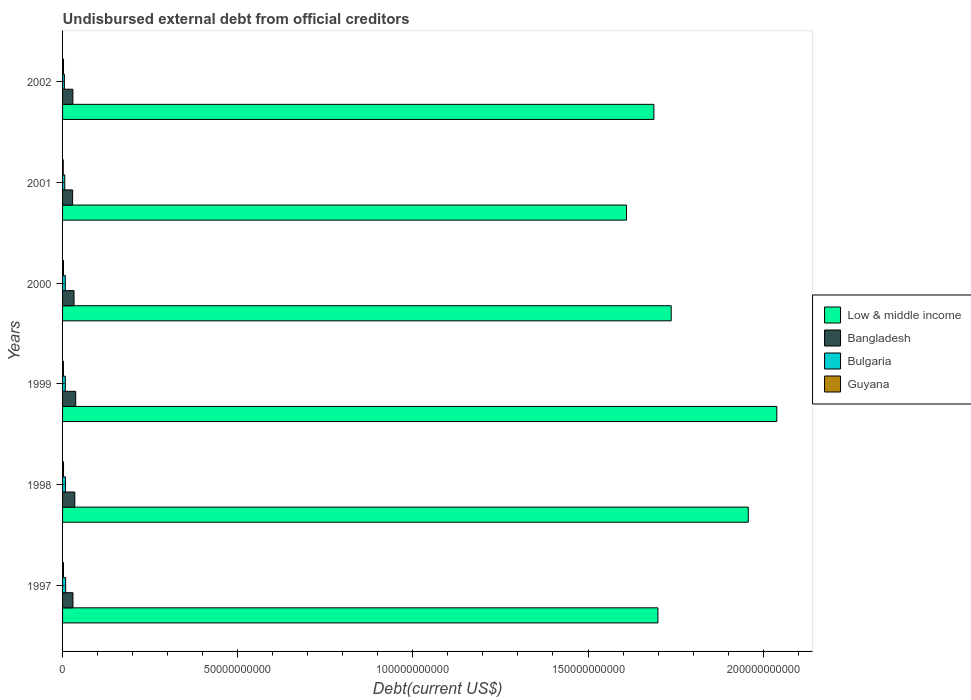How many different coloured bars are there?
Make the answer very short. 4. Are the number of bars per tick equal to the number of legend labels?
Give a very brief answer. Yes. How many bars are there on the 2nd tick from the bottom?
Your response must be concise. 4. What is the label of the 5th group of bars from the top?
Offer a terse response. 1998. In how many cases, is the number of bars for a given year not equal to the number of legend labels?
Ensure brevity in your answer.  0. What is the total debt in Guyana in 1999?
Provide a succinct answer. 2.46e+08. Across all years, what is the maximum total debt in Guyana?
Ensure brevity in your answer.  2.77e+08. Across all years, what is the minimum total debt in Guyana?
Provide a short and direct response. 2.00e+08. In which year was the total debt in Guyana minimum?
Give a very brief answer. 2001. What is the total total debt in Bulgaria in the graph?
Offer a terse response. 4.41e+09. What is the difference between the total debt in Guyana in 1998 and that in 2001?
Make the answer very short. 7.62e+07. What is the difference between the total debt in Bulgaria in 1997 and the total debt in Bangladesh in 2002?
Give a very brief answer. -2.07e+09. What is the average total debt in Bangladesh per year?
Offer a terse response. 3.22e+09. In the year 2000, what is the difference between the total debt in Bulgaria and total debt in Low & middle income?
Provide a succinct answer. -1.73e+11. In how many years, is the total debt in Guyana greater than 60000000000 US$?
Your answer should be very brief. 0. What is the ratio of the total debt in Guyana in 1999 to that in 2002?
Your response must be concise. 0.9. Is the difference between the total debt in Bulgaria in 1997 and 1999 greater than the difference between the total debt in Low & middle income in 1997 and 1999?
Your answer should be very brief. Yes. What is the difference between the highest and the second highest total debt in Bangladesh?
Make the answer very short. 2.61e+08. What is the difference between the highest and the lowest total debt in Guyana?
Provide a short and direct response. 7.62e+07. Is it the case that in every year, the sum of the total debt in Bulgaria and total debt in Bangladesh is greater than the sum of total debt in Guyana and total debt in Low & middle income?
Offer a very short reply. No. What does the 3rd bar from the top in 2002 represents?
Make the answer very short. Bangladesh. What does the 1st bar from the bottom in 2000 represents?
Offer a very short reply. Low & middle income. How many bars are there?
Give a very brief answer. 24. Are all the bars in the graph horizontal?
Make the answer very short. Yes. How many years are there in the graph?
Give a very brief answer. 6. What is the difference between two consecutive major ticks on the X-axis?
Your response must be concise. 5.00e+1. How many legend labels are there?
Offer a terse response. 4. What is the title of the graph?
Your answer should be very brief. Undisbursed external debt from official creditors. What is the label or title of the X-axis?
Give a very brief answer. Debt(current US$). What is the Debt(current US$) of Low & middle income in 1997?
Provide a short and direct response. 1.70e+11. What is the Debt(current US$) in Bangladesh in 1997?
Provide a succinct answer. 2.97e+09. What is the Debt(current US$) of Bulgaria in 1997?
Provide a short and direct response. 8.80e+08. What is the Debt(current US$) in Guyana in 1997?
Your response must be concise. 2.68e+08. What is the Debt(current US$) of Low & middle income in 1998?
Your response must be concise. 1.96e+11. What is the Debt(current US$) in Bangladesh in 1998?
Provide a succinct answer. 3.49e+09. What is the Debt(current US$) in Bulgaria in 1998?
Your answer should be very brief. 8.18e+08. What is the Debt(current US$) of Guyana in 1998?
Offer a terse response. 2.77e+08. What is the Debt(current US$) of Low & middle income in 1999?
Provide a succinct answer. 2.04e+11. What is the Debt(current US$) of Bangladesh in 1999?
Your answer should be compact. 3.76e+09. What is the Debt(current US$) of Bulgaria in 1999?
Provide a succinct answer. 7.88e+08. What is the Debt(current US$) in Guyana in 1999?
Your response must be concise. 2.46e+08. What is the Debt(current US$) in Low & middle income in 2000?
Your answer should be compact. 1.74e+11. What is the Debt(current US$) of Bangladesh in 2000?
Keep it short and to the point. 3.27e+09. What is the Debt(current US$) of Bulgaria in 2000?
Your answer should be very brief. 7.80e+08. What is the Debt(current US$) in Guyana in 2000?
Your response must be concise. 2.62e+08. What is the Debt(current US$) of Low & middle income in 2001?
Keep it short and to the point. 1.61e+11. What is the Debt(current US$) of Bangladesh in 2001?
Your answer should be very brief. 2.87e+09. What is the Debt(current US$) in Bulgaria in 2001?
Offer a terse response. 6.29e+08. What is the Debt(current US$) of Guyana in 2001?
Offer a terse response. 2.00e+08. What is the Debt(current US$) in Low & middle income in 2002?
Ensure brevity in your answer.  1.69e+11. What is the Debt(current US$) in Bangladesh in 2002?
Keep it short and to the point. 2.95e+09. What is the Debt(current US$) of Bulgaria in 2002?
Ensure brevity in your answer.  5.16e+08. What is the Debt(current US$) of Guyana in 2002?
Make the answer very short. 2.72e+08. Across all years, what is the maximum Debt(current US$) in Low & middle income?
Your answer should be compact. 2.04e+11. Across all years, what is the maximum Debt(current US$) of Bangladesh?
Give a very brief answer. 3.76e+09. Across all years, what is the maximum Debt(current US$) of Bulgaria?
Your response must be concise. 8.80e+08. Across all years, what is the maximum Debt(current US$) in Guyana?
Your answer should be compact. 2.77e+08. Across all years, what is the minimum Debt(current US$) of Low & middle income?
Keep it short and to the point. 1.61e+11. Across all years, what is the minimum Debt(current US$) of Bangladesh?
Offer a very short reply. 2.87e+09. Across all years, what is the minimum Debt(current US$) in Bulgaria?
Provide a succinct answer. 5.16e+08. Across all years, what is the minimum Debt(current US$) in Guyana?
Your answer should be very brief. 2.00e+08. What is the total Debt(current US$) of Low & middle income in the graph?
Make the answer very short. 1.07e+12. What is the total Debt(current US$) in Bangladesh in the graph?
Provide a short and direct response. 1.93e+1. What is the total Debt(current US$) of Bulgaria in the graph?
Ensure brevity in your answer.  4.41e+09. What is the total Debt(current US$) in Guyana in the graph?
Ensure brevity in your answer.  1.53e+09. What is the difference between the Debt(current US$) in Low & middle income in 1997 and that in 1998?
Provide a succinct answer. -2.58e+1. What is the difference between the Debt(current US$) in Bangladesh in 1997 and that in 1998?
Offer a terse response. -5.28e+08. What is the difference between the Debt(current US$) of Bulgaria in 1997 and that in 1998?
Your answer should be very brief. 6.22e+07. What is the difference between the Debt(current US$) in Guyana in 1997 and that in 1998?
Offer a very short reply. -8.23e+06. What is the difference between the Debt(current US$) in Low & middle income in 1997 and that in 1999?
Offer a terse response. -3.39e+1. What is the difference between the Debt(current US$) in Bangladesh in 1997 and that in 1999?
Offer a very short reply. -7.88e+08. What is the difference between the Debt(current US$) of Bulgaria in 1997 and that in 1999?
Your answer should be compact. 9.16e+07. What is the difference between the Debt(current US$) in Guyana in 1997 and that in 1999?
Make the answer very short. 2.25e+07. What is the difference between the Debt(current US$) of Low & middle income in 1997 and that in 2000?
Give a very brief answer. -3.79e+09. What is the difference between the Debt(current US$) of Bangladesh in 1997 and that in 2000?
Ensure brevity in your answer.  -3.04e+08. What is the difference between the Debt(current US$) in Bulgaria in 1997 and that in 2000?
Provide a succinct answer. 9.96e+07. What is the difference between the Debt(current US$) in Guyana in 1997 and that in 2000?
Your answer should be very brief. 5.98e+06. What is the difference between the Debt(current US$) of Low & middle income in 1997 and that in 2001?
Provide a short and direct response. 8.98e+09. What is the difference between the Debt(current US$) of Bangladesh in 1997 and that in 2001?
Your answer should be compact. 9.69e+07. What is the difference between the Debt(current US$) in Bulgaria in 1997 and that in 2001?
Your answer should be very brief. 2.50e+08. What is the difference between the Debt(current US$) in Guyana in 1997 and that in 2001?
Offer a very short reply. 6.80e+07. What is the difference between the Debt(current US$) of Low & middle income in 1997 and that in 2002?
Give a very brief answer. 1.16e+09. What is the difference between the Debt(current US$) of Bangladesh in 1997 and that in 2002?
Keep it short and to the point. 1.97e+07. What is the difference between the Debt(current US$) in Bulgaria in 1997 and that in 2002?
Offer a very short reply. 3.63e+08. What is the difference between the Debt(current US$) in Guyana in 1997 and that in 2002?
Make the answer very short. -3.79e+06. What is the difference between the Debt(current US$) of Low & middle income in 1998 and that in 1999?
Provide a succinct answer. -8.15e+09. What is the difference between the Debt(current US$) in Bangladesh in 1998 and that in 1999?
Ensure brevity in your answer.  -2.61e+08. What is the difference between the Debt(current US$) in Bulgaria in 1998 and that in 1999?
Your answer should be compact. 2.94e+07. What is the difference between the Debt(current US$) of Guyana in 1998 and that in 1999?
Keep it short and to the point. 3.07e+07. What is the difference between the Debt(current US$) of Low & middle income in 1998 and that in 2000?
Your answer should be very brief. 2.20e+1. What is the difference between the Debt(current US$) of Bangladesh in 1998 and that in 2000?
Offer a very short reply. 2.23e+08. What is the difference between the Debt(current US$) of Bulgaria in 1998 and that in 2000?
Your response must be concise. 3.74e+07. What is the difference between the Debt(current US$) of Guyana in 1998 and that in 2000?
Provide a short and direct response. 1.42e+07. What is the difference between the Debt(current US$) of Low & middle income in 1998 and that in 2001?
Ensure brevity in your answer.  3.48e+1. What is the difference between the Debt(current US$) in Bangladesh in 1998 and that in 2001?
Keep it short and to the point. 6.24e+08. What is the difference between the Debt(current US$) of Bulgaria in 1998 and that in 2001?
Offer a terse response. 1.88e+08. What is the difference between the Debt(current US$) of Guyana in 1998 and that in 2001?
Keep it short and to the point. 7.62e+07. What is the difference between the Debt(current US$) of Low & middle income in 1998 and that in 2002?
Offer a very short reply. 2.70e+1. What is the difference between the Debt(current US$) of Bangladesh in 1998 and that in 2002?
Your answer should be compact. 5.47e+08. What is the difference between the Debt(current US$) of Bulgaria in 1998 and that in 2002?
Provide a short and direct response. 3.01e+08. What is the difference between the Debt(current US$) of Guyana in 1998 and that in 2002?
Give a very brief answer. 4.44e+06. What is the difference between the Debt(current US$) in Low & middle income in 1999 and that in 2000?
Offer a very short reply. 3.02e+1. What is the difference between the Debt(current US$) of Bangladesh in 1999 and that in 2000?
Give a very brief answer. 4.84e+08. What is the difference between the Debt(current US$) of Bulgaria in 1999 and that in 2000?
Your answer should be very brief. 8.00e+06. What is the difference between the Debt(current US$) in Guyana in 1999 and that in 2000?
Give a very brief answer. -1.65e+07. What is the difference between the Debt(current US$) in Low & middle income in 1999 and that in 2001?
Keep it short and to the point. 4.29e+1. What is the difference between the Debt(current US$) of Bangladesh in 1999 and that in 2001?
Keep it short and to the point. 8.85e+08. What is the difference between the Debt(current US$) in Bulgaria in 1999 and that in 2001?
Your answer should be very brief. 1.59e+08. What is the difference between the Debt(current US$) in Guyana in 1999 and that in 2001?
Offer a very short reply. 4.55e+07. What is the difference between the Debt(current US$) of Low & middle income in 1999 and that in 2002?
Give a very brief answer. 3.51e+1. What is the difference between the Debt(current US$) of Bangladesh in 1999 and that in 2002?
Offer a terse response. 8.08e+08. What is the difference between the Debt(current US$) of Bulgaria in 1999 and that in 2002?
Keep it short and to the point. 2.72e+08. What is the difference between the Debt(current US$) in Guyana in 1999 and that in 2002?
Provide a succinct answer. -2.63e+07. What is the difference between the Debt(current US$) in Low & middle income in 2000 and that in 2001?
Ensure brevity in your answer.  1.28e+1. What is the difference between the Debt(current US$) of Bangladesh in 2000 and that in 2001?
Ensure brevity in your answer.  4.01e+08. What is the difference between the Debt(current US$) of Bulgaria in 2000 and that in 2001?
Your answer should be compact. 1.51e+08. What is the difference between the Debt(current US$) in Guyana in 2000 and that in 2001?
Give a very brief answer. 6.20e+07. What is the difference between the Debt(current US$) of Low & middle income in 2000 and that in 2002?
Give a very brief answer. 4.95e+09. What is the difference between the Debt(current US$) in Bangladesh in 2000 and that in 2002?
Give a very brief answer. 3.24e+08. What is the difference between the Debt(current US$) in Bulgaria in 2000 and that in 2002?
Make the answer very short. 2.64e+08. What is the difference between the Debt(current US$) in Guyana in 2000 and that in 2002?
Your answer should be compact. -9.77e+06. What is the difference between the Debt(current US$) of Low & middle income in 2001 and that in 2002?
Your response must be concise. -7.81e+09. What is the difference between the Debt(current US$) of Bangladesh in 2001 and that in 2002?
Offer a very short reply. -7.71e+07. What is the difference between the Debt(current US$) in Bulgaria in 2001 and that in 2002?
Offer a terse response. 1.13e+08. What is the difference between the Debt(current US$) of Guyana in 2001 and that in 2002?
Your answer should be compact. -7.18e+07. What is the difference between the Debt(current US$) of Low & middle income in 1997 and the Debt(current US$) of Bangladesh in 1998?
Ensure brevity in your answer.  1.66e+11. What is the difference between the Debt(current US$) in Low & middle income in 1997 and the Debt(current US$) in Bulgaria in 1998?
Offer a terse response. 1.69e+11. What is the difference between the Debt(current US$) in Low & middle income in 1997 and the Debt(current US$) in Guyana in 1998?
Your answer should be very brief. 1.70e+11. What is the difference between the Debt(current US$) in Bangladesh in 1997 and the Debt(current US$) in Bulgaria in 1998?
Offer a terse response. 2.15e+09. What is the difference between the Debt(current US$) of Bangladesh in 1997 and the Debt(current US$) of Guyana in 1998?
Provide a short and direct response. 2.69e+09. What is the difference between the Debt(current US$) of Bulgaria in 1997 and the Debt(current US$) of Guyana in 1998?
Provide a short and direct response. 6.03e+08. What is the difference between the Debt(current US$) in Low & middle income in 1997 and the Debt(current US$) in Bangladesh in 1999?
Your answer should be very brief. 1.66e+11. What is the difference between the Debt(current US$) in Low & middle income in 1997 and the Debt(current US$) in Bulgaria in 1999?
Make the answer very short. 1.69e+11. What is the difference between the Debt(current US$) in Low & middle income in 1997 and the Debt(current US$) in Guyana in 1999?
Your answer should be very brief. 1.70e+11. What is the difference between the Debt(current US$) of Bangladesh in 1997 and the Debt(current US$) of Bulgaria in 1999?
Offer a terse response. 2.18e+09. What is the difference between the Debt(current US$) of Bangladesh in 1997 and the Debt(current US$) of Guyana in 1999?
Your answer should be very brief. 2.72e+09. What is the difference between the Debt(current US$) in Bulgaria in 1997 and the Debt(current US$) in Guyana in 1999?
Keep it short and to the point. 6.34e+08. What is the difference between the Debt(current US$) of Low & middle income in 1997 and the Debt(current US$) of Bangladesh in 2000?
Give a very brief answer. 1.67e+11. What is the difference between the Debt(current US$) of Low & middle income in 1997 and the Debt(current US$) of Bulgaria in 2000?
Make the answer very short. 1.69e+11. What is the difference between the Debt(current US$) in Low & middle income in 1997 and the Debt(current US$) in Guyana in 2000?
Your answer should be compact. 1.70e+11. What is the difference between the Debt(current US$) in Bangladesh in 1997 and the Debt(current US$) in Bulgaria in 2000?
Your response must be concise. 2.19e+09. What is the difference between the Debt(current US$) of Bangladesh in 1997 and the Debt(current US$) of Guyana in 2000?
Your response must be concise. 2.70e+09. What is the difference between the Debt(current US$) in Bulgaria in 1997 and the Debt(current US$) in Guyana in 2000?
Your response must be concise. 6.17e+08. What is the difference between the Debt(current US$) of Low & middle income in 1997 and the Debt(current US$) of Bangladesh in 2001?
Offer a very short reply. 1.67e+11. What is the difference between the Debt(current US$) of Low & middle income in 1997 and the Debt(current US$) of Bulgaria in 2001?
Give a very brief answer. 1.69e+11. What is the difference between the Debt(current US$) in Low & middle income in 1997 and the Debt(current US$) in Guyana in 2001?
Keep it short and to the point. 1.70e+11. What is the difference between the Debt(current US$) of Bangladesh in 1997 and the Debt(current US$) of Bulgaria in 2001?
Keep it short and to the point. 2.34e+09. What is the difference between the Debt(current US$) of Bangladesh in 1997 and the Debt(current US$) of Guyana in 2001?
Offer a terse response. 2.77e+09. What is the difference between the Debt(current US$) in Bulgaria in 1997 and the Debt(current US$) in Guyana in 2001?
Provide a short and direct response. 6.79e+08. What is the difference between the Debt(current US$) of Low & middle income in 1997 and the Debt(current US$) of Bangladesh in 2002?
Provide a succinct answer. 1.67e+11. What is the difference between the Debt(current US$) in Low & middle income in 1997 and the Debt(current US$) in Bulgaria in 2002?
Your answer should be compact. 1.69e+11. What is the difference between the Debt(current US$) in Low & middle income in 1997 and the Debt(current US$) in Guyana in 2002?
Provide a short and direct response. 1.70e+11. What is the difference between the Debt(current US$) in Bangladesh in 1997 and the Debt(current US$) in Bulgaria in 2002?
Your answer should be very brief. 2.45e+09. What is the difference between the Debt(current US$) in Bangladesh in 1997 and the Debt(current US$) in Guyana in 2002?
Provide a succinct answer. 2.69e+09. What is the difference between the Debt(current US$) in Bulgaria in 1997 and the Debt(current US$) in Guyana in 2002?
Offer a very short reply. 6.07e+08. What is the difference between the Debt(current US$) in Low & middle income in 1998 and the Debt(current US$) in Bangladesh in 1999?
Provide a succinct answer. 1.92e+11. What is the difference between the Debt(current US$) in Low & middle income in 1998 and the Debt(current US$) in Bulgaria in 1999?
Offer a very short reply. 1.95e+11. What is the difference between the Debt(current US$) in Low & middle income in 1998 and the Debt(current US$) in Guyana in 1999?
Keep it short and to the point. 1.96e+11. What is the difference between the Debt(current US$) of Bangladesh in 1998 and the Debt(current US$) of Bulgaria in 1999?
Ensure brevity in your answer.  2.71e+09. What is the difference between the Debt(current US$) in Bangladesh in 1998 and the Debt(current US$) in Guyana in 1999?
Your answer should be very brief. 3.25e+09. What is the difference between the Debt(current US$) of Bulgaria in 1998 and the Debt(current US$) of Guyana in 1999?
Offer a very short reply. 5.72e+08. What is the difference between the Debt(current US$) of Low & middle income in 1998 and the Debt(current US$) of Bangladesh in 2000?
Your answer should be very brief. 1.92e+11. What is the difference between the Debt(current US$) in Low & middle income in 1998 and the Debt(current US$) in Bulgaria in 2000?
Your response must be concise. 1.95e+11. What is the difference between the Debt(current US$) in Low & middle income in 1998 and the Debt(current US$) in Guyana in 2000?
Your answer should be compact. 1.95e+11. What is the difference between the Debt(current US$) of Bangladesh in 1998 and the Debt(current US$) of Bulgaria in 2000?
Give a very brief answer. 2.71e+09. What is the difference between the Debt(current US$) of Bangladesh in 1998 and the Debt(current US$) of Guyana in 2000?
Keep it short and to the point. 3.23e+09. What is the difference between the Debt(current US$) in Bulgaria in 1998 and the Debt(current US$) in Guyana in 2000?
Ensure brevity in your answer.  5.55e+08. What is the difference between the Debt(current US$) of Low & middle income in 1998 and the Debt(current US$) of Bangladesh in 2001?
Make the answer very short. 1.93e+11. What is the difference between the Debt(current US$) in Low & middle income in 1998 and the Debt(current US$) in Bulgaria in 2001?
Give a very brief answer. 1.95e+11. What is the difference between the Debt(current US$) of Low & middle income in 1998 and the Debt(current US$) of Guyana in 2001?
Keep it short and to the point. 1.96e+11. What is the difference between the Debt(current US$) of Bangladesh in 1998 and the Debt(current US$) of Bulgaria in 2001?
Your response must be concise. 2.87e+09. What is the difference between the Debt(current US$) of Bangladesh in 1998 and the Debt(current US$) of Guyana in 2001?
Offer a very short reply. 3.29e+09. What is the difference between the Debt(current US$) in Bulgaria in 1998 and the Debt(current US$) in Guyana in 2001?
Give a very brief answer. 6.17e+08. What is the difference between the Debt(current US$) in Low & middle income in 1998 and the Debt(current US$) in Bangladesh in 2002?
Provide a short and direct response. 1.93e+11. What is the difference between the Debt(current US$) of Low & middle income in 1998 and the Debt(current US$) of Bulgaria in 2002?
Ensure brevity in your answer.  1.95e+11. What is the difference between the Debt(current US$) in Low & middle income in 1998 and the Debt(current US$) in Guyana in 2002?
Provide a short and direct response. 1.95e+11. What is the difference between the Debt(current US$) of Bangladesh in 1998 and the Debt(current US$) of Bulgaria in 2002?
Your response must be concise. 2.98e+09. What is the difference between the Debt(current US$) of Bangladesh in 1998 and the Debt(current US$) of Guyana in 2002?
Give a very brief answer. 3.22e+09. What is the difference between the Debt(current US$) of Bulgaria in 1998 and the Debt(current US$) of Guyana in 2002?
Make the answer very short. 5.45e+08. What is the difference between the Debt(current US$) in Low & middle income in 1999 and the Debt(current US$) in Bangladesh in 2000?
Provide a succinct answer. 2.01e+11. What is the difference between the Debt(current US$) in Low & middle income in 1999 and the Debt(current US$) in Bulgaria in 2000?
Give a very brief answer. 2.03e+11. What is the difference between the Debt(current US$) of Low & middle income in 1999 and the Debt(current US$) of Guyana in 2000?
Your answer should be very brief. 2.04e+11. What is the difference between the Debt(current US$) in Bangladesh in 1999 and the Debt(current US$) in Bulgaria in 2000?
Ensure brevity in your answer.  2.98e+09. What is the difference between the Debt(current US$) of Bangladesh in 1999 and the Debt(current US$) of Guyana in 2000?
Offer a terse response. 3.49e+09. What is the difference between the Debt(current US$) of Bulgaria in 1999 and the Debt(current US$) of Guyana in 2000?
Offer a terse response. 5.26e+08. What is the difference between the Debt(current US$) of Low & middle income in 1999 and the Debt(current US$) of Bangladesh in 2001?
Provide a succinct answer. 2.01e+11. What is the difference between the Debt(current US$) in Low & middle income in 1999 and the Debt(current US$) in Bulgaria in 2001?
Provide a short and direct response. 2.03e+11. What is the difference between the Debt(current US$) of Low & middle income in 1999 and the Debt(current US$) of Guyana in 2001?
Offer a terse response. 2.04e+11. What is the difference between the Debt(current US$) in Bangladesh in 1999 and the Debt(current US$) in Bulgaria in 2001?
Give a very brief answer. 3.13e+09. What is the difference between the Debt(current US$) of Bangladesh in 1999 and the Debt(current US$) of Guyana in 2001?
Keep it short and to the point. 3.55e+09. What is the difference between the Debt(current US$) of Bulgaria in 1999 and the Debt(current US$) of Guyana in 2001?
Provide a short and direct response. 5.88e+08. What is the difference between the Debt(current US$) of Low & middle income in 1999 and the Debt(current US$) of Bangladesh in 2002?
Keep it short and to the point. 2.01e+11. What is the difference between the Debt(current US$) in Low & middle income in 1999 and the Debt(current US$) in Bulgaria in 2002?
Provide a succinct answer. 2.03e+11. What is the difference between the Debt(current US$) in Low & middle income in 1999 and the Debt(current US$) in Guyana in 2002?
Make the answer very short. 2.04e+11. What is the difference between the Debt(current US$) of Bangladesh in 1999 and the Debt(current US$) of Bulgaria in 2002?
Your response must be concise. 3.24e+09. What is the difference between the Debt(current US$) in Bangladesh in 1999 and the Debt(current US$) in Guyana in 2002?
Ensure brevity in your answer.  3.48e+09. What is the difference between the Debt(current US$) of Bulgaria in 1999 and the Debt(current US$) of Guyana in 2002?
Your response must be concise. 5.16e+08. What is the difference between the Debt(current US$) of Low & middle income in 2000 and the Debt(current US$) of Bangladesh in 2001?
Your answer should be compact. 1.71e+11. What is the difference between the Debt(current US$) in Low & middle income in 2000 and the Debt(current US$) in Bulgaria in 2001?
Offer a terse response. 1.73e+11. What is the difference between the Debt(current US$) of Low & middle income in 2000 and the Debt(current US$) of Guyana in 2001?
Provide a succinct answer. 1.74e+11. What is the difference between the Debt(current US$) of Bangladesh in 2000 and the Debt(current US$) of Bulgaria in 2001?
Provide a succinct answer. 2.64e+09. What is the difference between the Debt(current US$) in Bangladesh in 2000 and the Debt(current US$) in Guyana in 2001?
Your response must be concise. 3.07e+09. What is the difference between the Debt(current US$) in Bulgaria in 2000 and the Debt(current US$) in Guyana in 2001?
Ensure brevity in your answer.  5.80e+08. What is the difference between the Debt(current US$) in Low & middle income in 2000 and the Debt(current US$) in Bangladesh in 2002?
Your response must be concise. 1.71e+11. What is the difference between the Debt(current US$) in Low & middle income in 2000 and the Debt(current US$) in Bulgaria in 2002?
Give a very brief answer. 1.73e+11. What is the difference between the Debt(current US$) in Low & middle income in 2000 and the Debt(current US$) in Guyana in 2002?
Give a very brief answer. 1.73e+11. What is the difference between the Debt(current US$) in Bangladesh in 2000 and the Debt(current US$) in Bulgaria in 2002?
Keep it short and to the point. 2.76e+09. What is the difference between the Debt(current US$) in Bangladesh in 2000 and the Debt(current US$) in Guyana in 2002?
Your answer should be very brief. 3.00e+09. What is the difference between the Debt(current US$) in Bulgaria in 2000 and the Debt(current US$) in Guyana in 2002?
Your answer should be very brief. 5.08e+08. What is the difference between the Debt(current US$) in Low & middle income in 2001 and the Debt(current US$) in Bangladesh in 2002?
Provide a succinct answer. 1.58e+11. What is the difference between the Debt(current US$) of Low & middle income in 2001 and the Debt(current US$) of Bulgaria in 2002?
Offer a terse response. 1.60e+11. What is the difference between the Debt(current US$) of Low & middle income in 2001 and the Debt(current US$) of Guyana in 2002?
Give a very brief answer. 1.61e+11. What is the difference between the Debt(current US$) in Bangladesh in 2001 and the Debt(current US$) in Bulgaria in 2002?
Ensure brevity in your answer.  2.35e+09. What is the difference between the Debt(current US$) in Bangladesh in 2001 and the Debt(current US$) in Guyana in 2002?
Offer a terse response. 2.60e+09. What is the difference between the Debt(current US$) of Bulgaria in 2001 and the Debt(current US$) of Guyana in 2002?
Make the answer very short. 3.57e+08. What is the average Debt(current US$) of Low & middle income per year?
Your answer should be very brief. 1.79e+11. What is the average Debt(current US$) of Bangladesh per year?
Keep it short and to the point. 3.22e+09. What is the average Debt(current US$) of Bulgaria per year?
Provide a short and direct response. 7.35e+08. What is the average Debt(current US$) in Guyana per year?
Provide a short and direct response. 2.54e+08. In the year 1997, what is the difference between the Debt(current US$) in Low & middle income and Debt(current US$) in Bangladesh?
Your answer should be compact. 1.67e+11. In the year 1997, what is the difference between the Debt(current US$) of Low & middle income and Debt(current US$) of Bulgaria?
Offer a very short reply. 1.69e+11. In the year 1997, what is the difference between the Debt(current US$) in Low & middle income and Debt(current US$) in Guyana?
Keep it short and to the point. 1.70e+11. In the year 1997, what is the difference between the Debt(current US$) of Bangladesh and Debt(current US$) of Bulgaria?
Provide a short and direct response. 2.09e+09. In the year 1997, what is the difference between the Debt(current US$) in Bangladesh and Debt(current US$) in Guyana?
Your answer should be compact. 2.70e+09. In the year 1997, what is the difference between the Debt(current US$) of Bulgaria and Debt(current US$) of Guyana?
Offer a terse response. 6.11e+08. In the year 1998, what is the difference between the Debt(current US$) in Low & middle income and Debt(current US$) in Bangladesh?
Provide a short and direct response. 1.92e+11. In the year 1998, what is the difference between the Debt(current US$) in Low & middle income and Debt(current US$) in Bulgaria?
Your response must be concise. 1.95e+11. In the year 1998, what is the difference between the Debt(current US$) of Low & middle income and Debt(current US$) of Guyana?
Your answer should be compact. 1.95e+11. In the year 1998, what is the difference between the Debt(current US$) in Bangladesh and Debt(current US$) in Bulgaria?
Your answer should be compact. 2.68e+09. In the year 1998, what is the difference between the Debt(current US$) of Bangladesh and Debt(current US$) of Guyana?
Give a very brief answer. 3.22e+09. In the year 1998, what is the difference between the Debt(current US$) in Bulgaria and Debt(current US$) in Guyana?
Provide a short and direct response. 5.41e+08. In the year 1999, what is the difference between the Debt(current US$) in Low & middle income and Debt(current US$) in Bangladesh?
Your answer should be very brief. 2.00e+11. In the year 1999, what is the difference between the Debt(current US$) of Low & middle income and Debt(current US$) of Bulgaria?
Your answer should be compact. 2.03e+11. In the year 1999, what is the difference between the Debt(current US$) of Low & middle income and Debt(current US$) of Guyana?
Offer a very short reply. 2.04e+11. In the year 1999, what is the difference between the Debt(current US$) of Bangladesh and Debt(current US$) of Bulgaria?
Ensure brevity in your answer.  2.97e+09. In the year 1999, what is the difference between the Debt(current US$) of Bangladesh and Debt(current US$) of Guyana?
Keep it short and to the point. 3.51e+09. In the year 1999, what is the difference between the Debt(current US$) of Bulgaria and Debt(current US$) of Guyana?
Offer a terse response. 5.42e+08. In the year 2000, what is the difference between the Debt(current US$) of Low & middle income and Debt(current US$) of Bangladesh?
Offer a terse response. 1.70e+11. In the year 2000, what is the difference between the Debt(current US$) of Low & middle income and Debt(current US$) of Bulgaria?
Offer a very short reply. 1.73e+11. In the year 2000, what is the difference between the Debt(current US$) in Low & middle income and Debt(current US$) in Guyana?
Offer a very short reply. 1.73e+11. In the year 2000, what is the difference between the Debt(current US$) of Bangladesh and Debt(current US$) of Bulgaria?
Give a very brief answer. 2.49e+09. In the year 2000, what is the difference between the Debt(current US$) in Bangladesh and Debt(current US$) in Guyana?
Provide a short and direct response. 3.01e+09. In the year 2000, what is the difference between the Debt(current US$) of Bulgaria and Debt(current US$) of Guyana?
Offer a very short reply. 5.18e+08. In the year 2001, what is the difference between the Debt(current US$) of Low & middle income and Debt(current US$) of Bangladesh?
Make the answer very short. 1.58e+11. In the year 2001, what is the difference between the Debt(current US$) of Low & middle income and Debt(current US$) of Bulgaria?
Keep it short and to the point. 1.60e+11. In the year 2001, what is the difference between the Debt(current US$) of Low & middle income and Debt(current US$) of Guyana?
Offer a terse response. 1.61e+11. In the year 2001, what is the difference between the Debt(current US$) in Bangladesh and Debt(current US$) in Bulgaria?
Give a very brief answer. 2.24e+09. In the year 2001, what is the difference between the Debt(current US$) of Bangladesh and Debt(current US$) of Guyana?
Offer a terse response. 2.67e+09. In the year 2001, what is the difference between the Debt(current US$) in Bulgaria and Debt(current US$) in Guyana?
Your response must be concise. 4.29e+08. In the year 2002, what is the difference between the Debt(current US$) in Low & middle income and Debt(current US$) in Bangladesh?
Offer a very short reply. 1.66e+11. In the year 2002, what is the difference between the Debt(current US$) of Low & middle income and Debt(current US$) of Bulgaria?
Keep it short and to the point. 1.68e+11. In the year 2002, what is the difference between the Debt(current US$) in Low & middle income and Debt(current US$) in Guyana?
Ensure brevity in your answer.  1.69e+11. In the year 2002, what is the difference between the Debt(current US$) of Bangladesh and Debt(current US$) of Bulgaria?
Provide a short and direct response. 2.43e+09. In the year 2002, what is the difference between the Debt(current US$) of Bangladesh and Debt(current US$) of Guyana?
Your response must be concise. 2.68e+09. In the year 2002, what is the difference between the Debt(current US$) in Bulgaria and Debt(current US$) in Guyana?
Ensure brevity in your answer.  2.44e+08. What is the ratio of the Debt(current US$) in Low & middle income in 1997 to that in 1998?
Make the answer very short. 0.87. What is the ratio of the Debt(current US$) in Bangladesh in 1997 to that in 1998?
Your response must be concise. 0.85. What is the ratio of the Debt(current US$) in Bulgaria in 1997 to that in 1998?
Ensure brevity in your answer.  1.08. What is the ratio of the Debt(current US$) in Guyana in 1997 to that in 1998?
Provide a short and direct response. 0.97. What is the ratio of the Debt(current US$) of Low & middle income in 1997 to that in 1999?
Make the answer very short. 0.83. What is the ratio of the Debt(current US$) in Bangladesh in 1997 to that in 1999?
Offer a terse response. 0.79. What is the ratio of the Debt(current US$) in Bulgaria in 1997 to that in 1999?
Your answer should be very brief. 1.12. What is the ratio of the Debt(current US$) in Guyana in 1997 to that in 1999?
Keep it short and to the point. 1.09. What is the ratio of the Debt(current US$) of Low & middle income in 1997 to that in 2000?
Keep it short and to the point. 0.98. What is the ratio of the Debt(current US$) of Bangladesh in 1997 to that in 2000?
Offer a very short reply. 0.91. What is the ratio of the Debt(current US$) in Bulgaria in 1997 to that in 2000?
Your answer should be very brief. 1.13. What is the ratio of the Debt(current US$) of Guyana in 1997 to that in 2000?
Offer a very short reply. 1.02. What is the ratio of the Debt(current US$) of Low & middle income in 1997 to that in 2001?
Provide a short and direct response. 1.06. What is the ratio of the Debt(current US$) in Bangladesh in 1997 to that in 2001?
Provide a succinct answer. 1.03. What is the ratio of the Debt(current US$) of Bulgaria in 1997 to that in 2001?
Your response must be concise. 1.4. What is the ratio of the Debt(current US$) in Guyana in 1997 to that in 2001?
Keep it short and to the point. 1.34. What is the ratio of the Debt(current US$) of Bangladesh in 1997 to that in 2002?
Your answer should be compact. 1.01. What is the ratio of the Debt(current US$) of Bulgaria in 1997 to that in 2002?
Make the answer very short. 1.7. What is the ratio of the Debt(current US$) of Guyana in 1997 to that in 2002?
Your answer should be very brief. 0.99. What is the ratio of the Debt(current US$) in Low & middle income in 1998 to that in 1999?
Give a very brief answer. 0.96. What is the ratio of the Debt(current US$) in Bangladesh in 1998 to that in 1999?
Ensure brevity in your answer.  0.93. What is the ratio of the Debt(current US$) of Bulgaria in 1998 to that in 1999?
Provide a short and direct response. 1.04. What is the ratio of the Debt(current US$) of Guyana in 1998 to that in 1999?
Ensure brevity in your answer.  1.12. What is the ratio of the Debt(current US$) of Low & middle income in 1998 to that in 2000?
Provide a short and direct response. 1.13. What is the ratio of the Debt(current US$) of Bangladesh in 1998 to that in 2000?
Your answer should be very brief. 1.07. What is the ratio of the Debt(current US$) of Bulgaria in 1998 to that in 2000?
Offer a very short reply. 1.05. What is the ratio of the Debt(current US$) of Guyana in 1998 to that in 2000?
Your answer should be very brief. 1.05. What is the ratio of the Debt(current US$) of Low & middle income in 1998 to that in 2001?
Make the answer very short. 1.22. What is the ratio of the Debt(current US$) in Bangladesh in 1998 to that in 2001?
Ensure brevity in your answer.  1.22. What is the ratio of the Debt(current US$) of Bulgaria in 1998 to that in 2001?
Keep it short and to the point. 1.3. What is the ratio of the Debt(current US$) in Guyana in 1998 to that in 2001?
Your answer should be very brief. 1.38. What is the ratio of the Debt(current US$) of Low & middle income in 1998 to that in 2002?
Offer a very short reply. 1.16. What is the ratio of the Debt(current US$) in Bangladesh in 1998 to that in 2002?
Your answer should be compact. 1.19. What is the ratio of the Debt(current US$) in Bulgaria in 1998 to that in 2002?
Your answer should be compact. 1.58. What is the ratio of the Debt(current US$) in Guyana in 1998 to that in 2002?
Provide a succinct answer. 1.02. What is the ratio of the Debt(current US$) in Low & middle income in 1999 to that in 2000?
Your answer should be compact. 1.17. What is the ratio of the Debt(current US$) of Bangladesh in 1999 to that in 2000?
Your answer should be very brief. 1.15. What is the ratio of the Debt(current US$) in Bulgaria in 1999 to that in 2000?
Provide a succinct answer. 1.01. What is the ratio of the Debt(current US$) of Guyana in 1999 to that in 2000?
Provide a short and direct response. 0.94. What is the ratio of the Debt(current US$) in Low & middle income in 1999 to that in 2001?
Your response must be concise. 1.27. What is the ratio of the Debt(current US$) of Bangladesh in 1999 to that in 2001?
Give a very brief answer. 1.31. What is the ratio of the Debt(current US$) of Bulgaria in 1999 to that in 2001?
Provide a short and direct response. 1.25. What is the ratio of the Debt(current US$) in Guyana in 1999 to that in 2001?
Keep it short and to the point. 1.23. What is the ratio of the Debt(current US$) of Low & middle income in 1999 to that in 2002?
Your answer should be compact. 1.21. What is the ratio of the Debt(current US$) in Bangladesh in 1999 to that in 2002?
Provide a short and direct response. 1.27. What is the ratio of the Debt(current US$) in Bulgaria in 1999 to that in 2002?
Provide a short and direct response. 1.53. What is the ratio of the Debt(current US$) of Guyana in 1999 to that in 2002?
Make the answer very short. 0.9. What is the ratio of the Debt(current US$) of Low & middle income in 2000 to that in 2001?
Provide a succinct answer. 1.08. What is the ratio of the Debt(current US$) of Bangladesh in 2000 to that in 2001?
Make the answer very short. 1.14. What is the ratio of the Debt(current US$) of Bulgaria in 2000 to that in 2001?
Your answer should be compact. 1.24. What is the ratio of the Debt(current US$) of Guyana in 2000 to that in 2001?
Offer a terse response. 1.31. What is the ratio of the Debt(current US$) in Low & middle income in 2000 to that in 2002?
Your answer should be very brief. 1.03. What is the ratio of the Debt(current US$) of Bangladesh in 2000 to that in 2002?
Your answer should be compact. 1.11. What is the ratio of the Debt(current US$) of Bulgaria in 2000 to that in 2002?
Your answer should be compact. 1.51. What is the ratio of the Debt(current US$) of Guyana in 2000 to that in 2002?
Keep it short and to the point. 0.96. What is the ratio of the Debt(current US$) of Low & middle income in 2001 to that in 2002?
Offer a terse response. 0.95. What is the ratio of the Debt(current US$) in Bangladesh in 2001 to that in 2002?
Your answer should be compact. 0.97. What is the ratio of the Debt(current US$) of Bulgaria in 2001 to that in 2002?
Ensure brevity in your answer.  1.22. What is the ratio of the Debt(current US$) of Guyana in 2001 to that in 2002?
Ensure brevity in your answer.  0.74. What is the difference between the highest and the second highest Debt(current US$) of Low & middle income?
Make the answer very short. 8.15e+09. What is the difference between the highest and the second highest Debt(current US$) in Bangladesh?
Offer a very short reply. 2.61e+08. What is the difference between the highest and the second highest Debt(current US$) of Bulgaria?
Make the answer very short. 6.22e+07. What is the difference between the highest and the second highest Debt(current US$) in Guyana?
Make the answer very short. 4.44e+06. What is the difference between the highest and the lowest Debt(current US$) in Low & middle income?
Offer a terse response. 4.29e+1. What is the difference between the highest and the lowest Debt(current US$) in Bangladesh?
Your answer should be very brief. 8.85e+08. What is the difference between the highest and the lowest Debt(current US$) in Bulgaria?
Give a very brief answer. 3.63e+08. What is the difference between the highest and the lowest Debt(current US$) of Guyana?
Your response must be concise. 7.62e+07. 